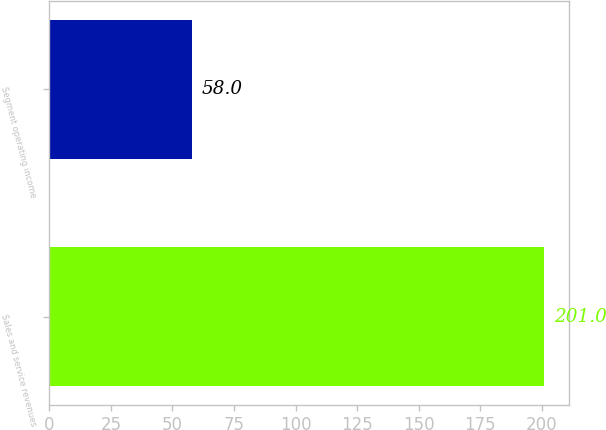Convert chart. <chart><loc_0><loc_0><loc_500><loc_500><bar_chart><fcel>Sales and service revenues<fcel>Segment operating income<nl><fcel>201<fcel>58<nl></chart> 